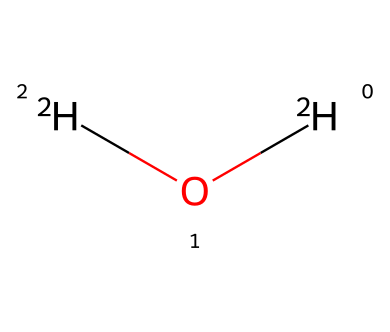What is the chemical name of this compound? The SMILES representation [2H]O[2H] denotes heavy water, which consists of two deuterium atoms (isotopes of hydrogen) and one oxygen atom. The structure indicates that the chemical name is deuterium oxide.
Answer: deuterium oxide How many deuterium atoms are present in the structure? In the SMILES representation [2H]O[2H], each [2H] indicates the presence of a deuterium atom. Since there are two instances of [2H], it denotes that there are two deuterium atoms in total.
Answer: two What type of bond is formed between oxygen and deuterium in this molecule? The structure reveals the connectivity in deuterium oxide, where the oxygen is bonded to each deuterium atom with a single covalent bond. Therefore, the bonds between oxygen and deuterium are single bonds.
Answer: single bond What differentiates deuterium from regular hydrogen in this chemical? The key differentiator between deuterium and regular hydrogen is the presence of an additional neutron in deuterium, giving it a greater atomic mass. This is reflected in the notation [2H] for deuterium compared to [1H] for regular hydrogen.
Answer: additional neutron Is this compound considered an isotope? Yes, deuterium is an isotope of hydrogen, which is indicated by the use of [2H] instead of [1H]. Since the chemical consists of deuterium and oxygen, it confirms that the compound is derived from isotopes.
Answer: yes What is a common application of deuterium oxide in everyday products? Deuterium oxide, or heavy water, is often used in scientific research and can also be found in some sports drinks, where it is used for its unique properties compared to regular water. This application highlights its importance in various formulations.
Answer: sports drinks 